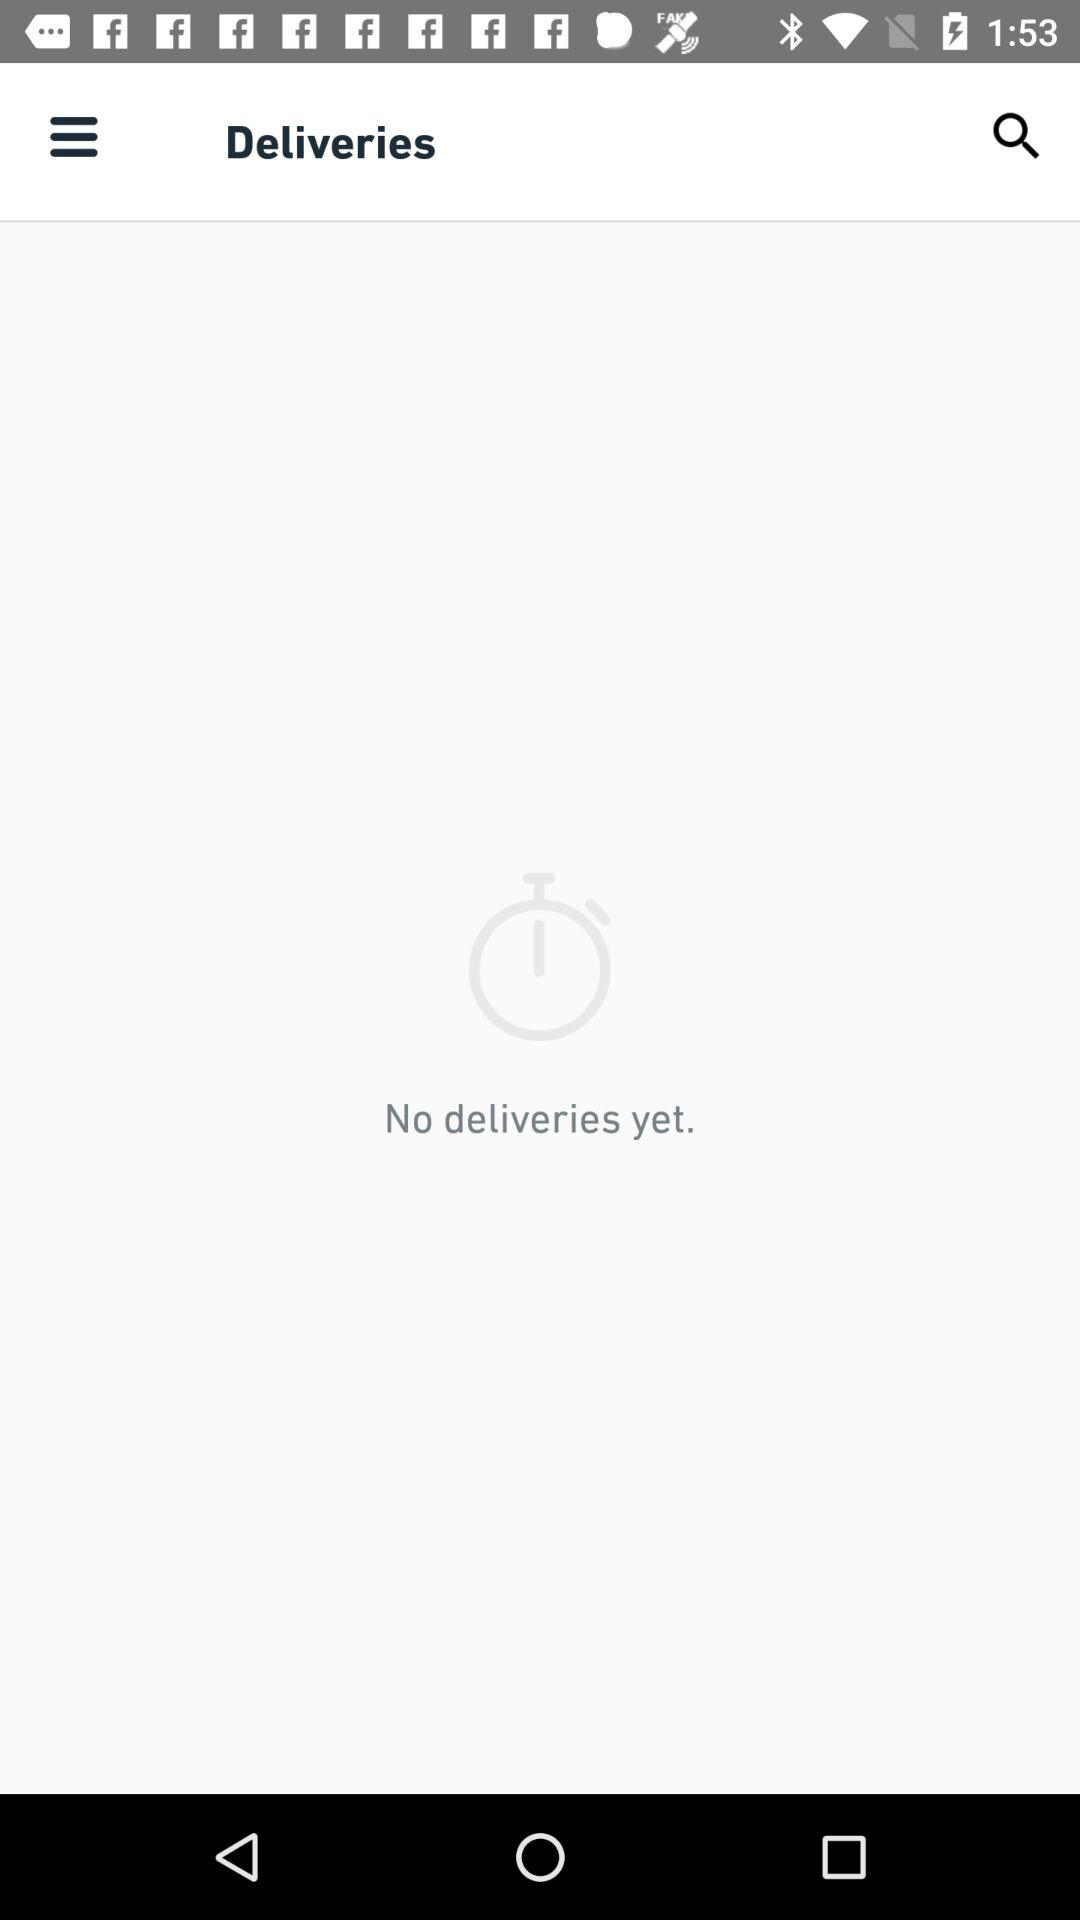How many deliveries have been made today?
Answer the question using a single word or phrase. 0 